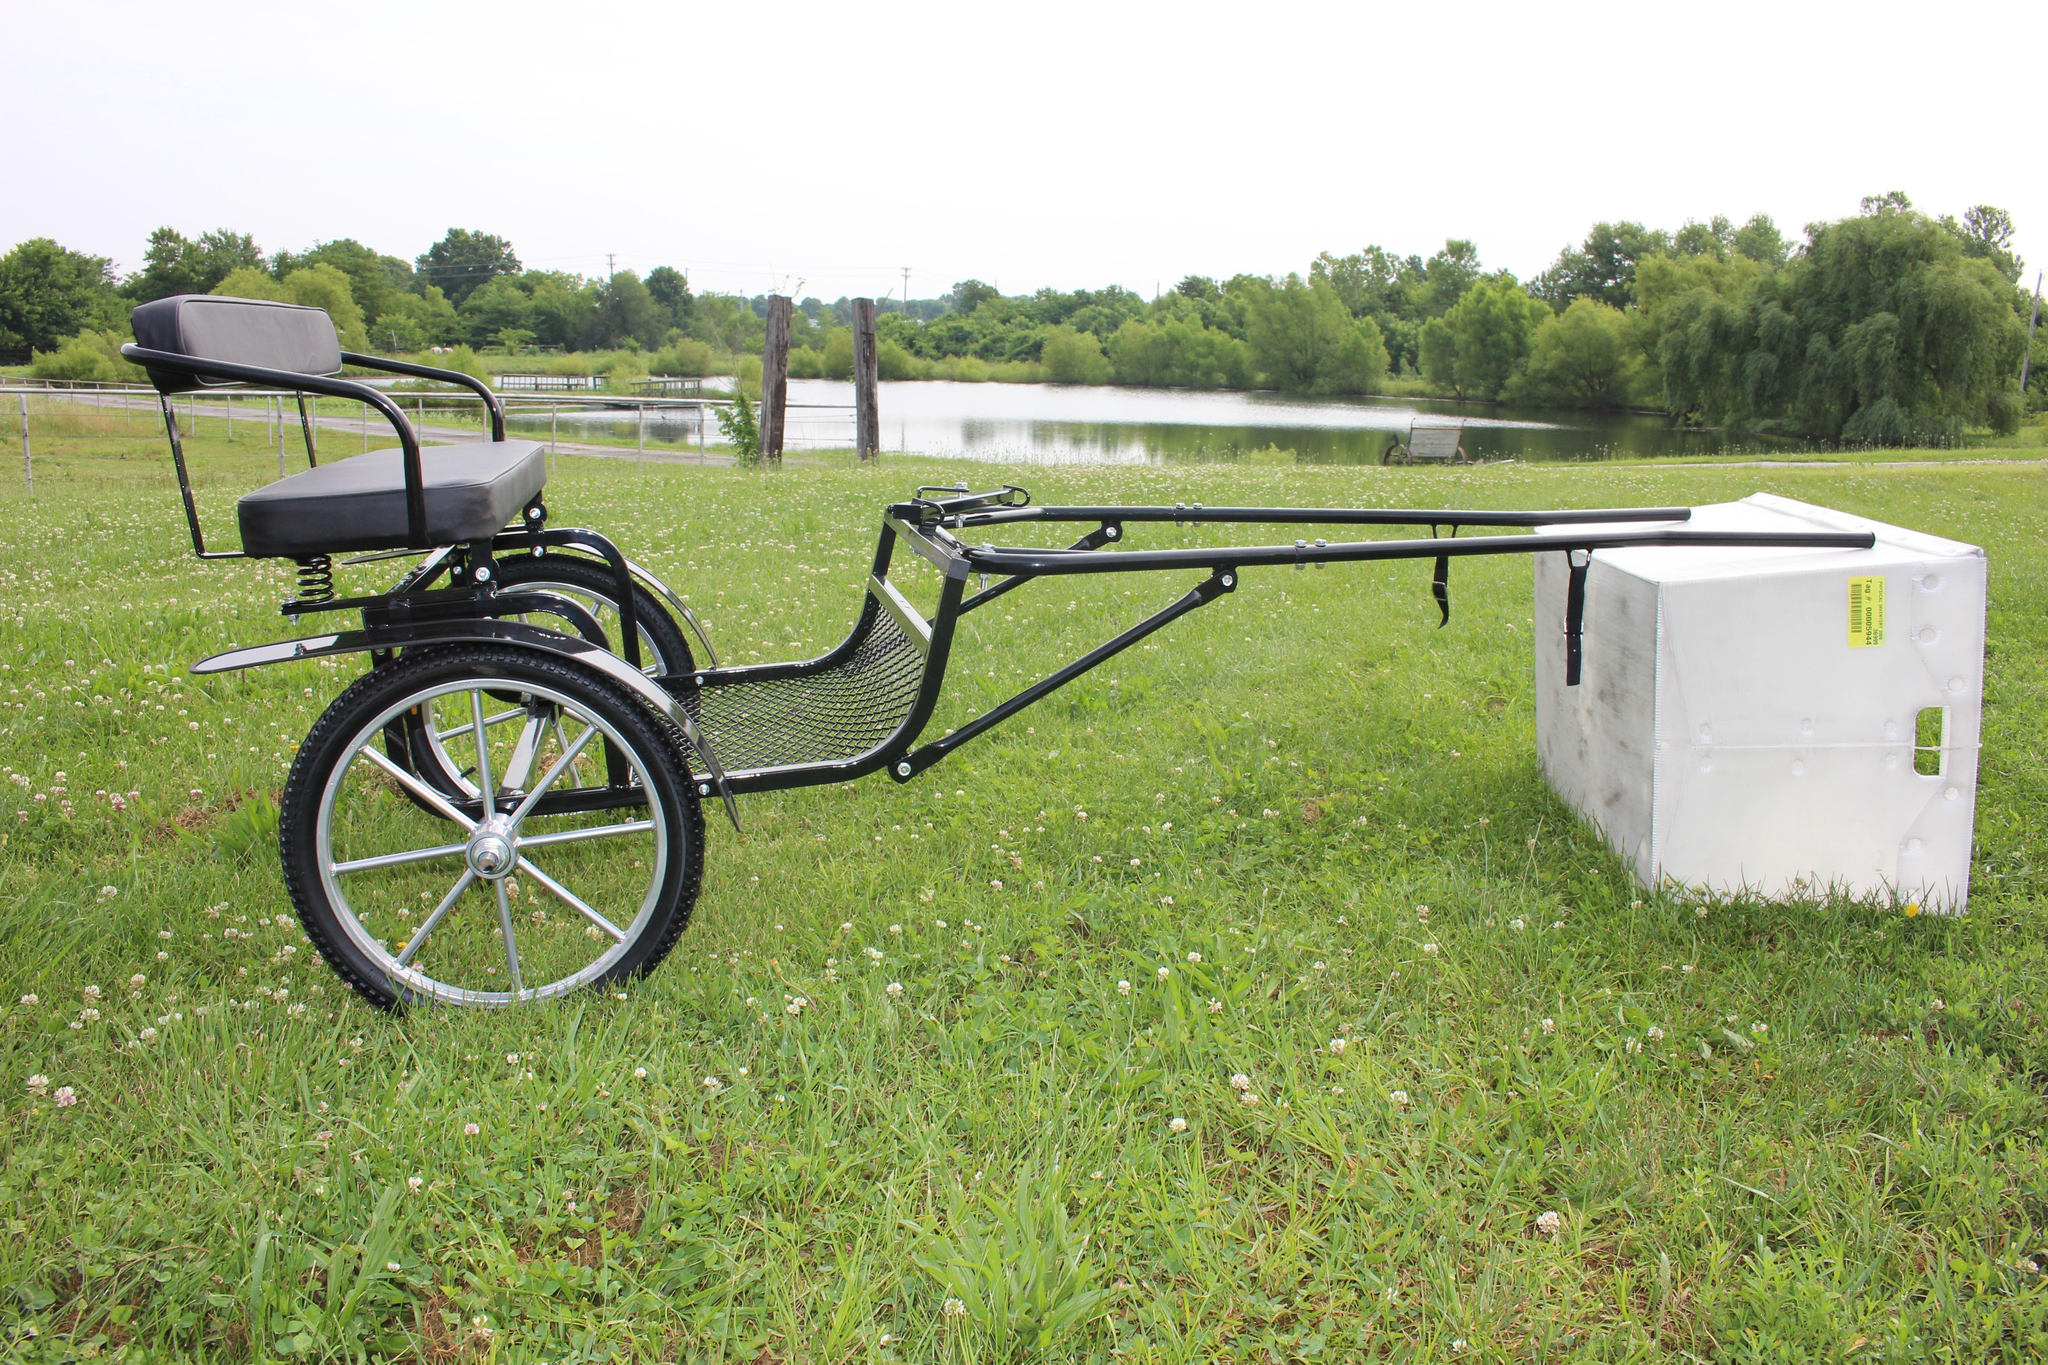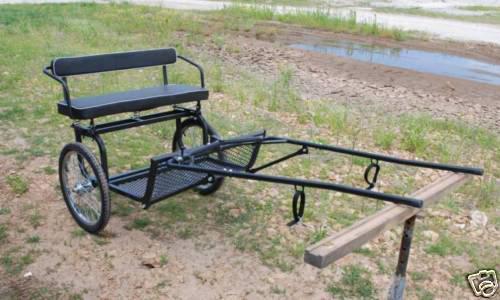The first image is the image on the left, the second image is the image on the right. Given the left and right images, does the statement "At least one image features a black cart with metal grating for the foot rest." hold true? Answer yes or no. Yes. The first image is the image on the left, the second image is the image on the right. Evaluate the accuracy of this statement regarding the images: "The foot rest of the buggy in the left photo is made from wooden slats.". Is it true? Answer yes or no. No. 